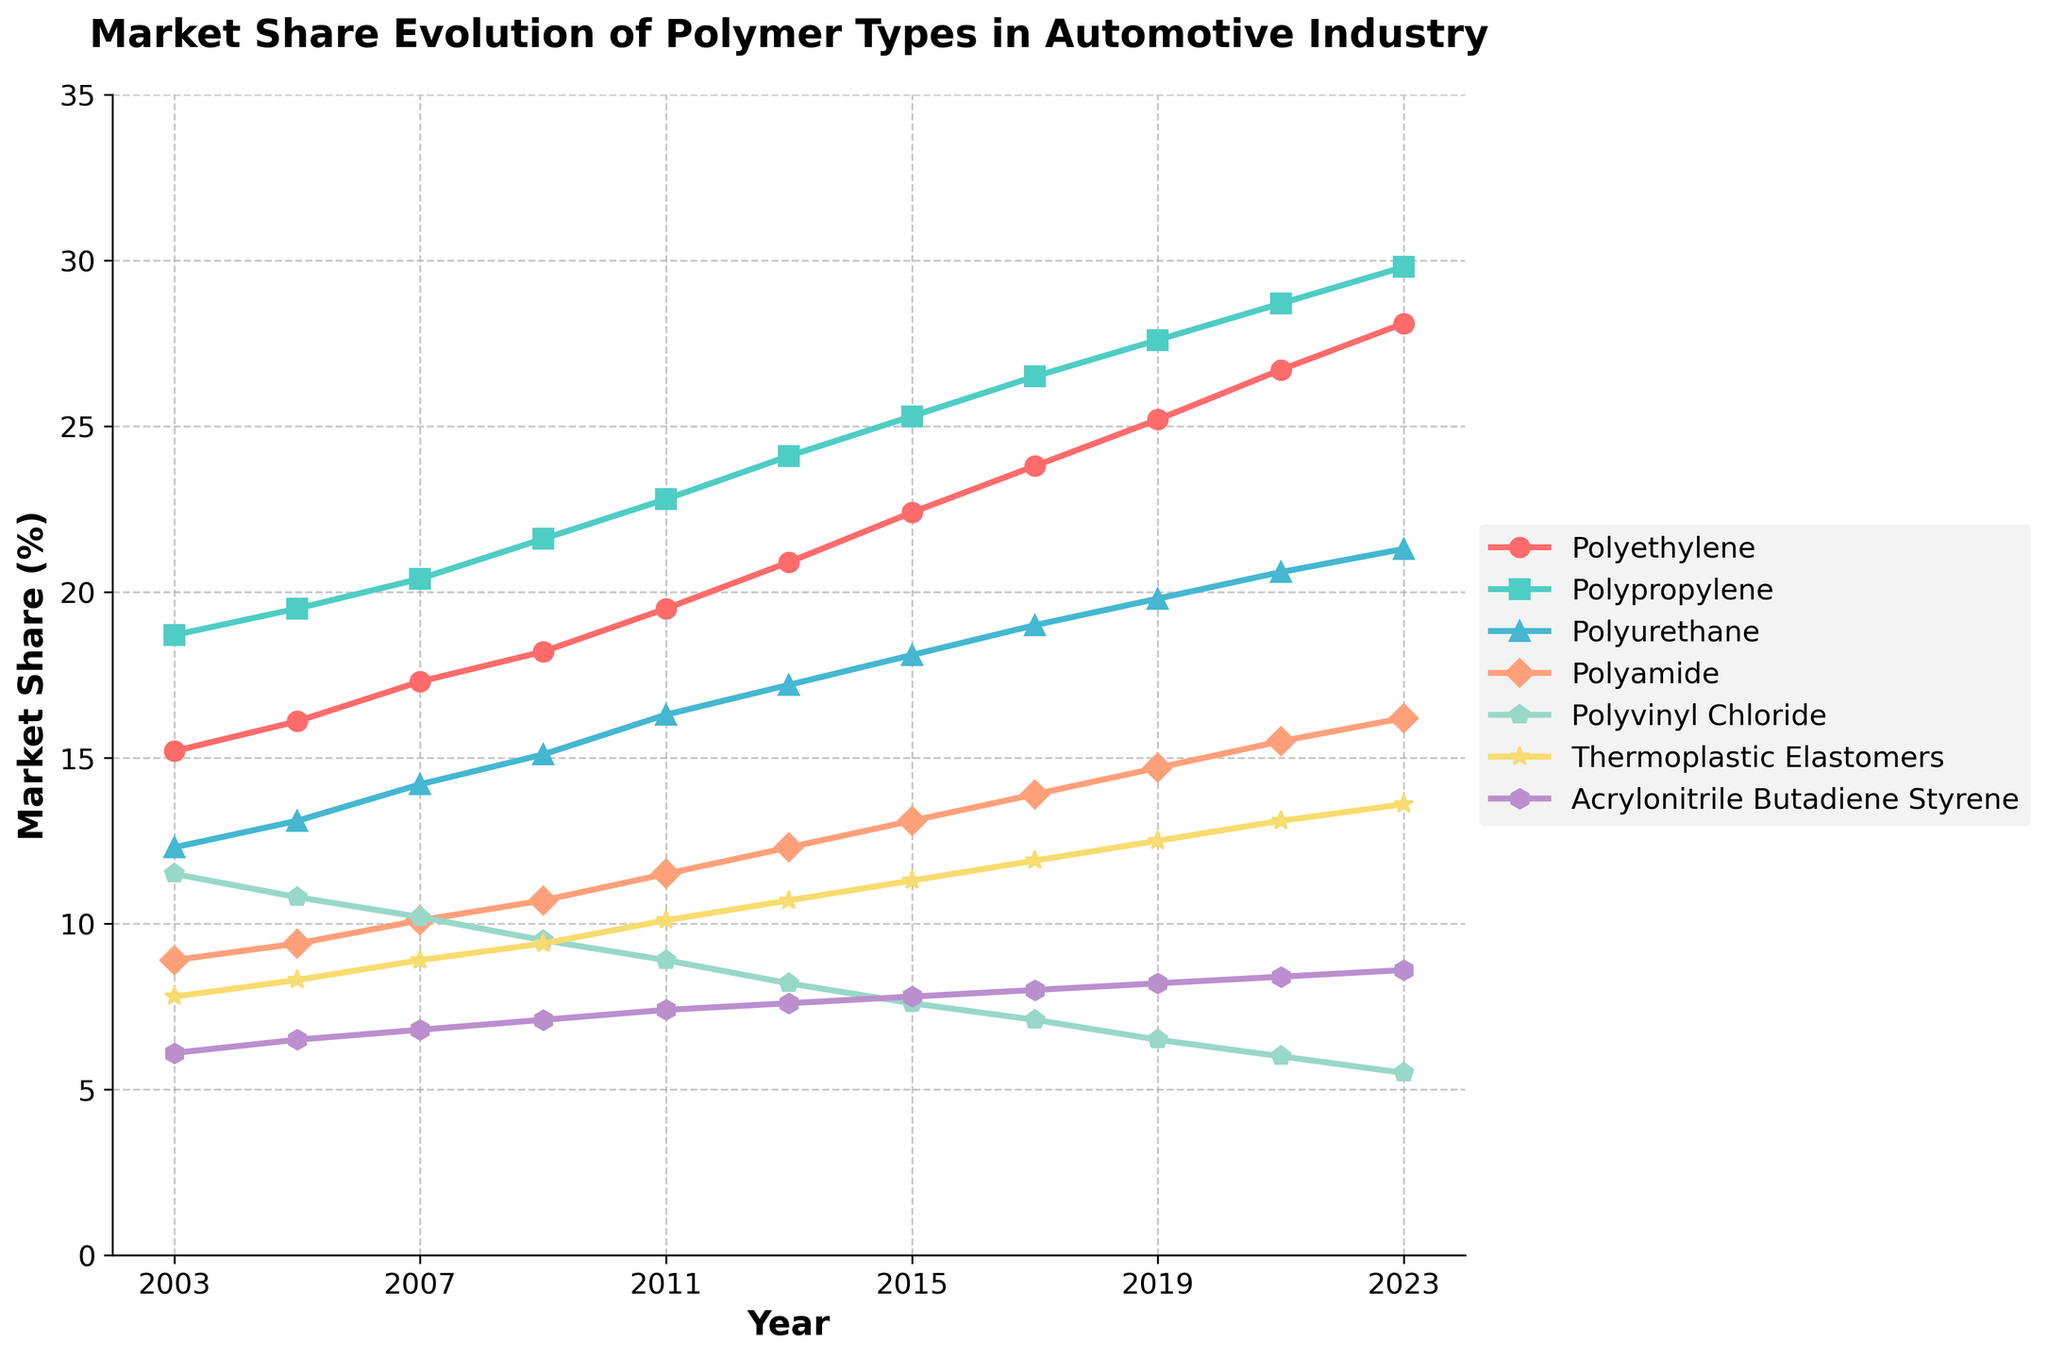what polymer has the largest market share in 2003, and what is its value? Look at the plot for the year 2003 and identify the highest curve, which represents the largest market share. The highest point is for Polypropylene. The y-value at this point is 18.7.
Answer: Polypropylene, 18.7% how does the market share of Polyethylene in 2023 compare to its market share in 2003? Identify the y-values for Polyethylene in 2003 and 2023 from the plot and calculate the difference. In 2003, it was 15.2%, and in 2023 it is 28.1%. The market share increased by 12.9%.
Answer: Increased by 12.9% which polymer type shows the most consistent growth over the years? Observe the slopes of each polymer type's line through the years. The Polymer with the smoothest and most consistent upward slope indicates the most consistent growth. Polypropylene's line shows the most consistent upward trend without fluctuation.
Answer: Polypropylene what two years saw the most significant increase in market share for Polyamide? Look at the plot and identify the years where the increase in market share for Polyamide is steepest by observing the slopes. The most significant slopes occur between 2011-2013 and 2017-2019.
Answer: 2011-2013, 2017-2019 compare the market share evolution of Polyvinyl Chloride and Acrylonitrile Butadiene Styrene from 2003 to 2023. What observations can you make? Observe the trends of Polyvinyl Chloride and Acrylonitrile Butadiene Styrene from 2003 to 2023. Polyvinyl Chloride shows a decline from 11.5% to 5.5%, while Acrylonitrile Butadiene Styrene shows a modest increase from 6.1% to 8.6%.
Answer: Polyvinyl Chloride decreased, Acrylonitrile Butadiene Styrene increased which polymer shows the highest market share increase from 2003 to 2023? Calculate the difference between the market shares in 2003 and 2023 for each polymer type. The polymer with the largest positive difference has the highest market share increase. Polyethylene increased from 15.2% to 28.1%, which is an increase of 12.9%, the highest among all polymers.
Answer: Polyethylene, 12.9% what is the average market share of Thermoplastic Elastomers across all the years presented? Sum the market share values for Thermoplastic Elastomers from the plot and calculate the average over the given years. The values are (7.8 + 8.3 + 8.9 + 9.4 + 10.1 + 10.7 + 11.3 + 11.9 + 12.5 + 13.1 + 13.6) which equals 117.6, and divide by 11 years: 117.6 / 11 = 10.69.
Answer: 10.69% between Polyamide and Polyurethane, which polymer had a larger relative increase in market share from 2003 to 2023? Calculate the relative increase for each polymer: (Polyamide 16.2 - 8.9) / 8.9 = 82.02%, (Polyurethane 21.3 - 12.3) / 12.3 = 73.17%. Polyamide's increase is larger.
Answer: Polyamide which polymer type has the least market share in 2023, and what is its value? Identify the polymer with the lowest y-value in 2023 from the plot. Polyvinyl Chloride is the lowest, with a market share of 5.5%.
Answer: Polyvinyl Chloride, 5.5% which polymer has exhibited the most significant drop in market share between any two consecutive years, and what was the percentage drop? Inspect each polymer's line and find the steepest decline between two consecutive years by calculating the differences. Polyvinyl Chloride dropped from 11.5% to 10.8% between 2003 and 2005, which is a drop of 0.7%. This polymer shows a general declining trend rather than one sharp drop. Polyvinyl Chloride between 2009 and 2011 dropped from 9.5% to 8.9%, which is a 0.6% drop. The most significant two-year drop is visually smaller than the trend of constant decline.
Answer: Polyvinyl Chloride, approximately 0.6-0.7% 